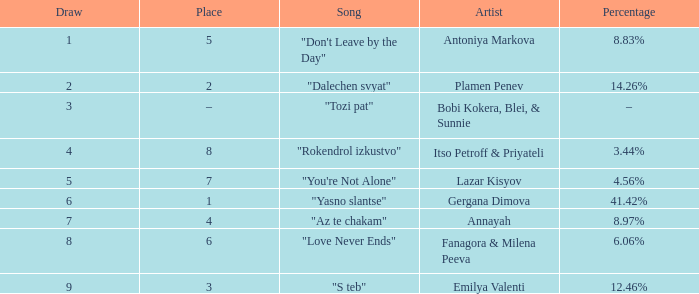Which Percentage has a Draw of 6? 41.42%. 